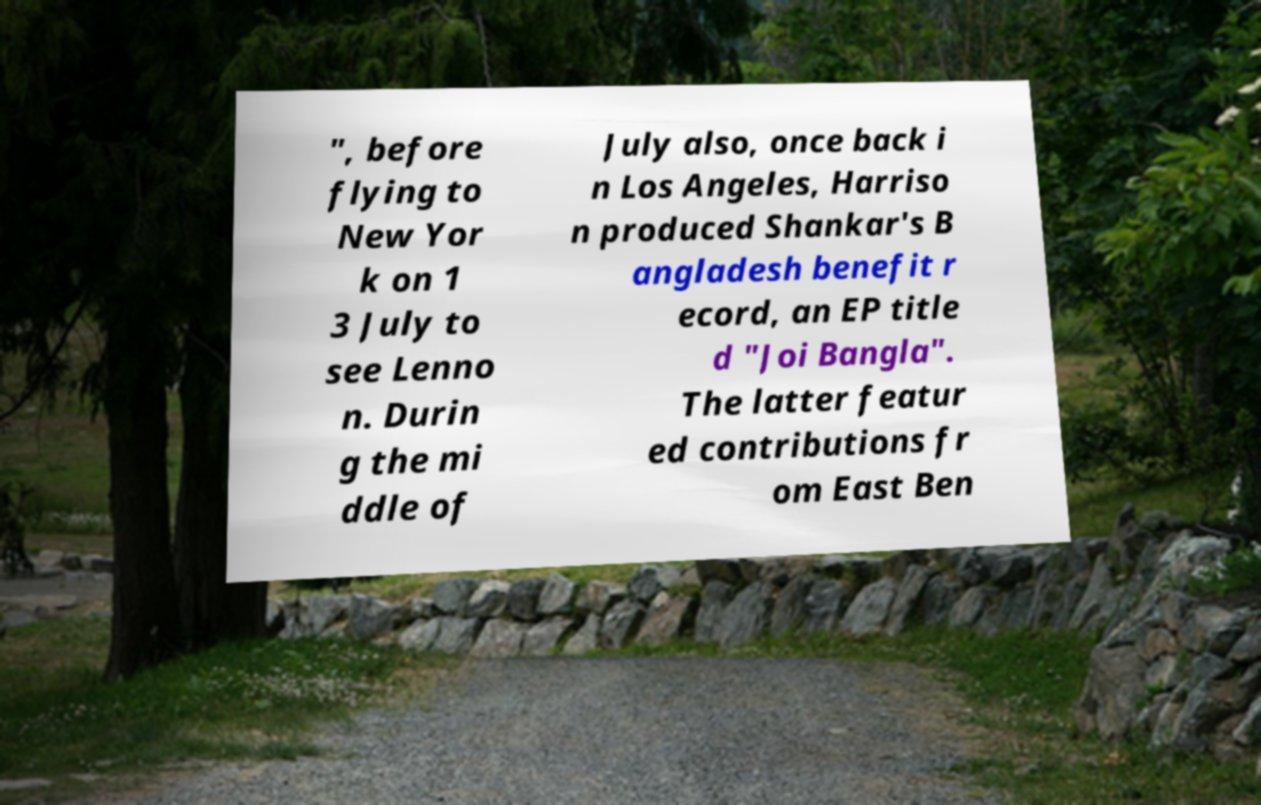Could you extract and type out the text from this image? ", before flying to New Yor k on 1 3 July to see Lenno n. Durin g the mi ddle of July also, once back i n Los Angeles, Harriso n produced Shankar's B angladesh benefit r ecord, an EP title d "Joi Bangla". The latter featur ed contributions fr om East Ben 